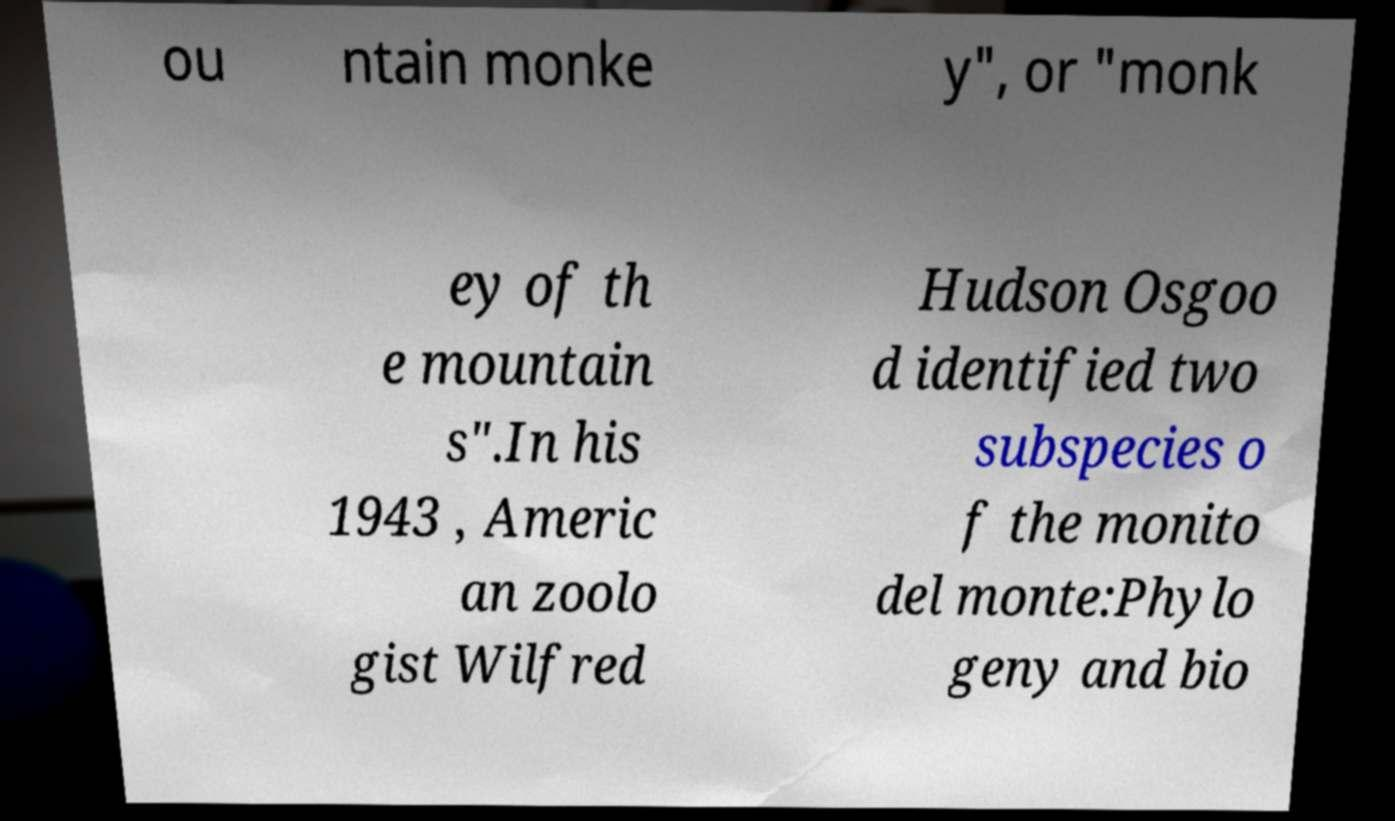What messages or text are displayed in this image? I need them in a readable, typed format. ou ntain monke y", or "monk ey of th e mountain s".In his 1943 , Americ an zoolo gist Wilfred Hudson Osgoo d identified two subspecies o f the monito del monte:Phylo geny and bio 